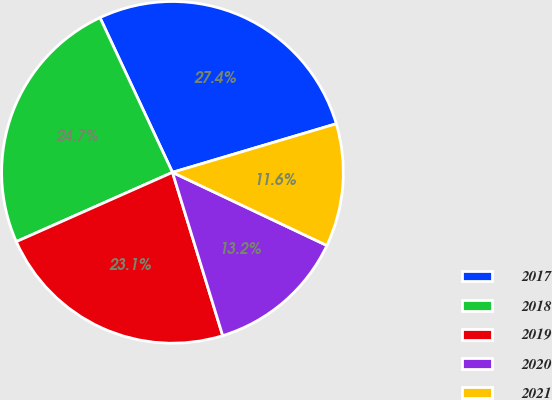Convert chart to OTSL. <chart><loc_0><loc_0><loc_500><loc_500><pie_chart><fcel>2017<fcel>2018<fcel>2019<fcel>2020<fcel>2021<nl><fcel>27.38%<fcel>24.67%<fcel>23.1%<fcel>13.21%<fcel>11.63%<nl></chart> 